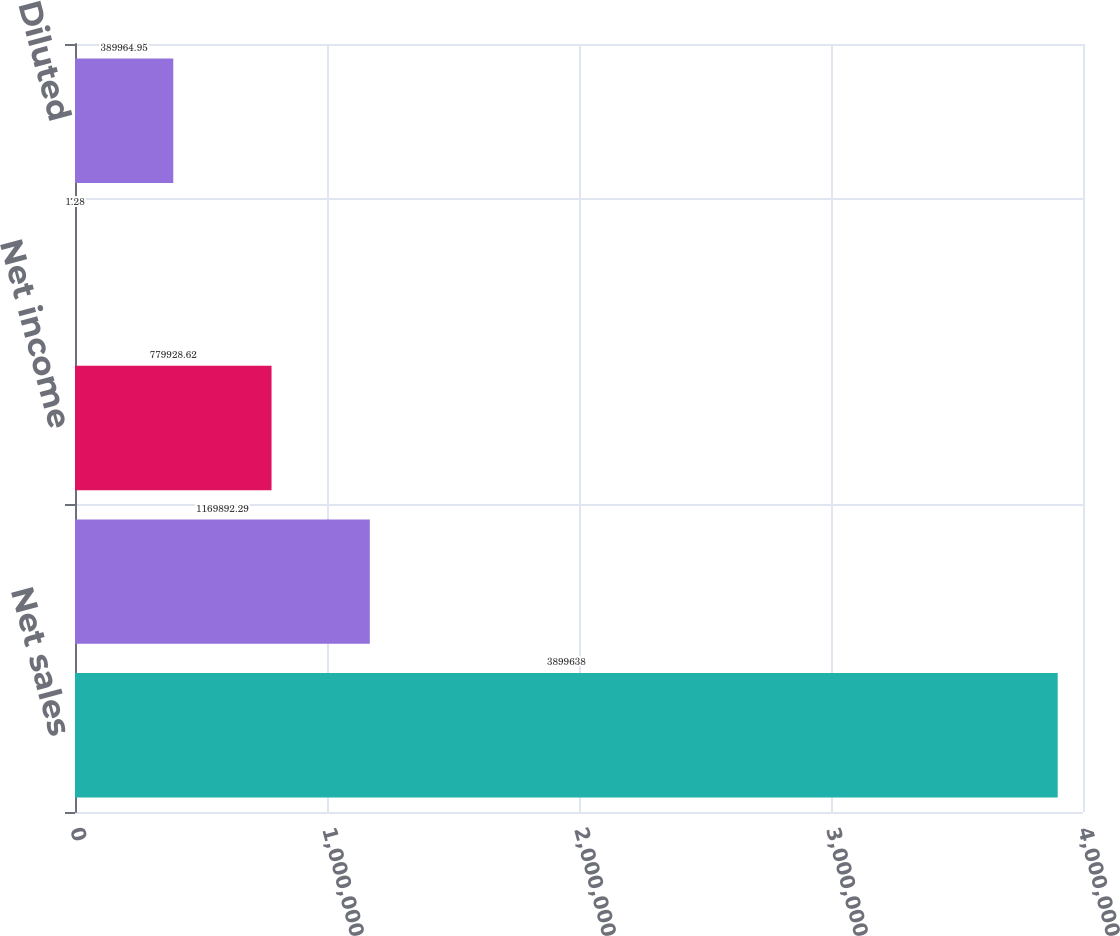<chart> <loc_0><loc_0><loc_500><loc_500><bar_chart><fcel>Net sales<fcel>Gross profit<fcel>Net income<fcel>Basic<fcel>Diluted<nl><fcel>3.89964e+06<fcel>1.16989e+06<fcel>779929<fcel>1.28<fcel>389965<nl></chart> 